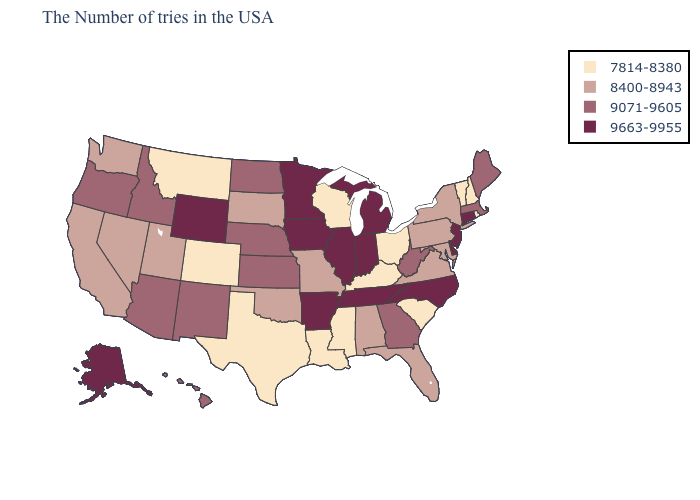Which states have the highest value in the USA?
Short answer required. Connecticut, New Jersey, Delaware, North Carolina, Michigan, Indiana, Tennessee, Illinois, Arkansas, Minnesota, Iowa, Wyoming, Alaska. What is the lowest value in states that border Ohio?
Short answer required. 7814-8380. What is the value of Illinois?
Concise answer only. 9663-9955. Which states have the highest value in the USA?
Write a very short answer. Connecticut, New Jersey, Delaware, North Carolina, Michigan, Indiana, Tennessee, Illinois, Arkansas, Minnesota, Iowa, Wyoming, Alaska. Does Tennessee have the highest value in the USA?
Concise answer only. Yes. Does the first symbol in the legend represent the smallest category?
Give a very brief answer. Yes. Among the states that border West Virginia , does Kentucky have the highest value?
Write a very short answer. No. Which states have the highest value in the USA?
Answer briefly. Connecticut, New Jersey, Delaware, North Carolina, Michigan, Indiana, Tennessee, Illinois, Arkansas, Minnesota, Iowa, Wyoming, Alaska. Does Iowa have a lower value than Indiana?
Keep it brief. No. Does the map have missing data?
Write a very short answer. No. Name the states that have a value in the range 7814-8380?
Quick response, please. Rhode Island, New Hampshire, Vermont, South Carolina, Ohio, Kentucky, Wisconsin, Mississippi, Louisiana, Texas, Colorado, Montana. What is the lowest value in the USA?
Quick response, please. 7814-8380. Does Indiana have the same value as Wyoming?
Be succinct. Yes. Which states have the lowest value in the USA?
Be succinct. Rhode Island, New Hampshire, Vermont, South Carolina, Ohio, Kentucky, Wisconsin, Mississippi, Louisiana, Texas, Colorado, Montana. What is the value of New York?
Quick response, please. 8400-8943. 